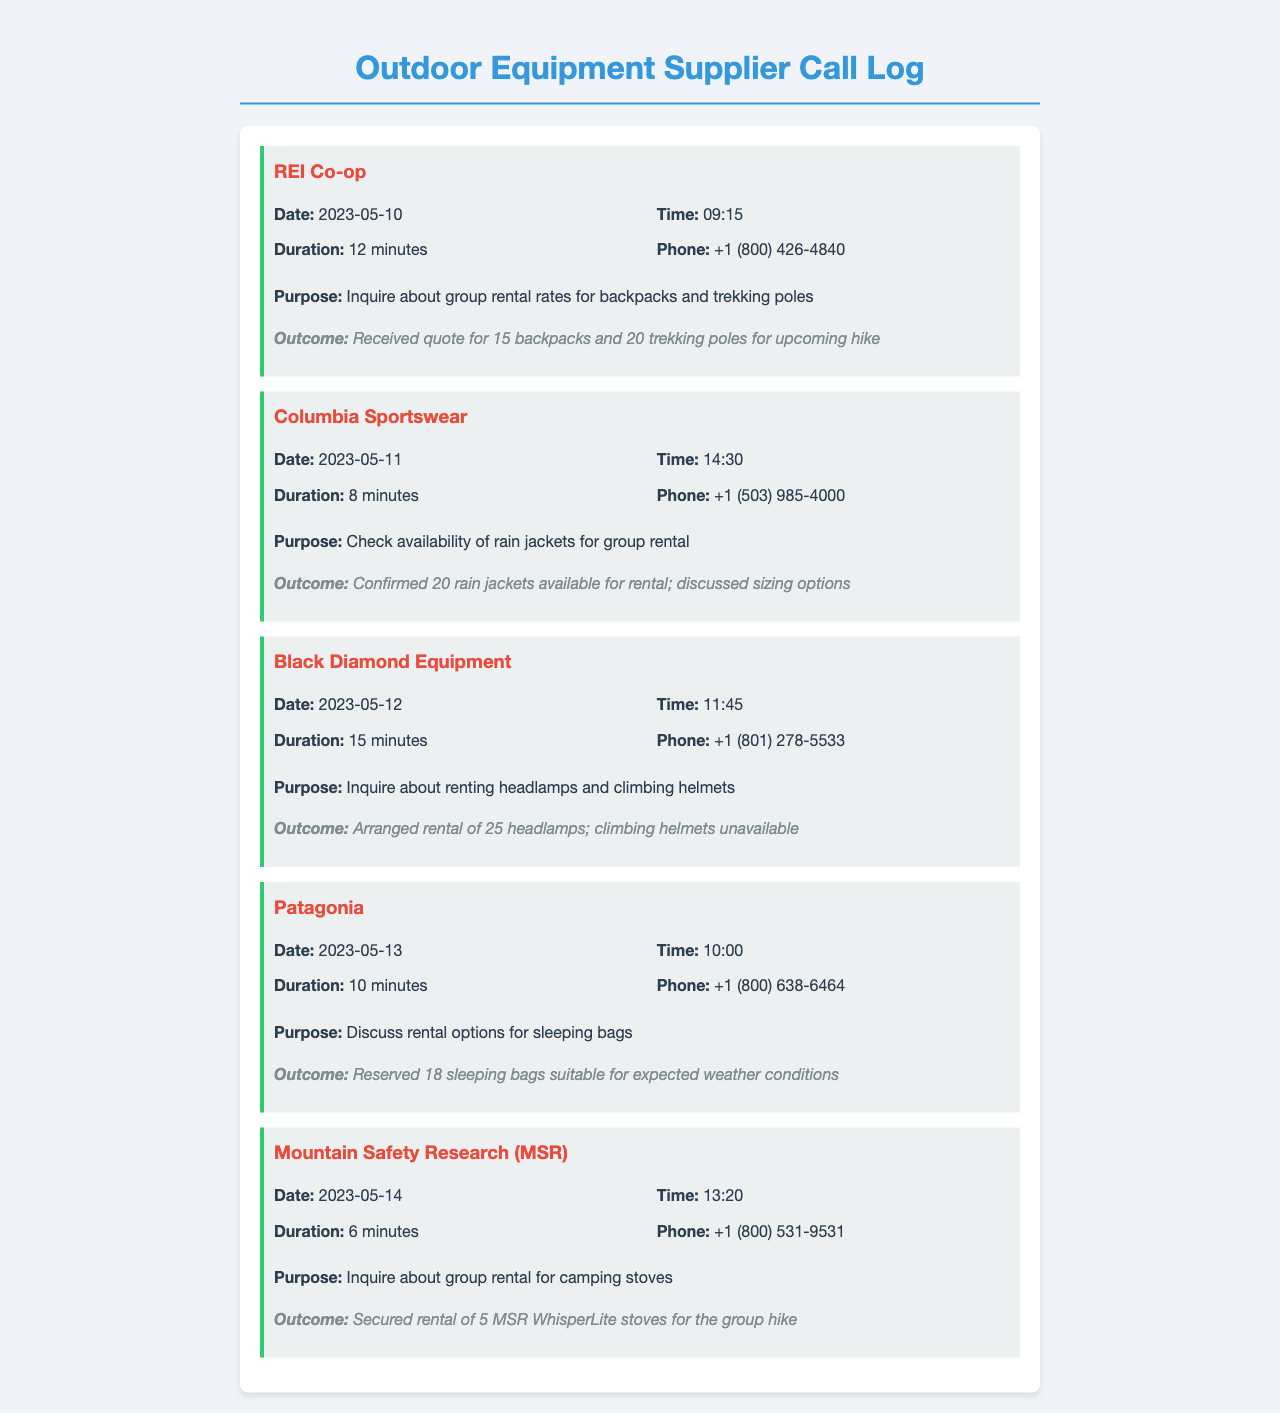what date was the call to REI Co-op made? The document specifies the date of the call to REI Co-op as 2023-05-10.
Answer: 2023-05-10 how long was the call with Columbia Sportswear? The call duration for the Columbia Sportswear entry is stated as 8 minutes.
Answer: 8 minutes how many rain jackets were confirmed available for rental? The document indicates that 20 rain jackets were confirmed available.
Answer: 20 rain jackets which supplier arranged rental of headlamps? The call log specifies that Black Diamond Equipment arranged the rental of headlamps.
Answer: Black Diamond Equipment what was discussed regarding climbing helmets? The outcome for Black Diamond Equipment notes that climbing helmets were unavailable.
Answer: Unavailable how many sleeping bags were reserved with Patagonia? The log mentions that 18 sleeping bags were reserved.
Answer: 18 sleeping bags which equipment was rented from Mountain Safety Research? The entry indicates that 5 MSR WhisperLite stoves were rented for the group.
Answer: 5 MSR WhisperLite stoves what was the purpose of the call to Patagonia? The purpose of the call to Patagonia was to discuss rental options for sleeping bags.
Answer: Discuss rental options for sleeping bags what is the outcome of the call made to REI Co-op? The call outcome for REI Co-op provided a quote for 15 backpacks and 20 trekking poles for the upcoming hike.
Answer: Received quote for 15 backpacks and 20 trekking poles 